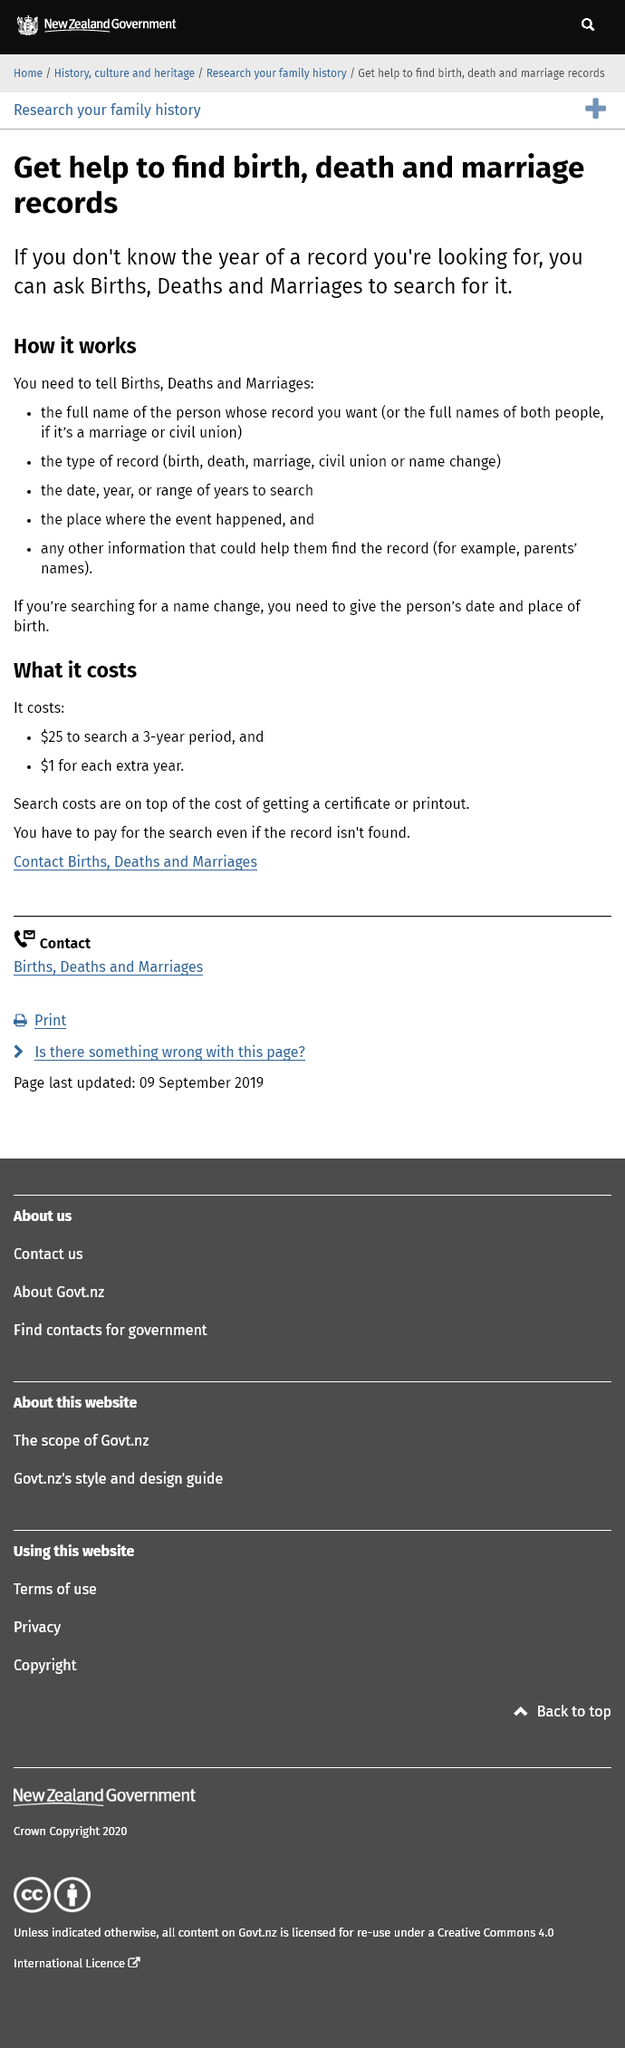Give some essential details in this illustration. The examples given for the type of record information include birth, death, marriage, civil union, or name change. It is possible to obtain assistance in locating birth, death, and marriage records by inquiring with Births, Deaths and Marriages to perform a search for the desired year. If a person is searching for a name change, they must provide their date and place of birth. 